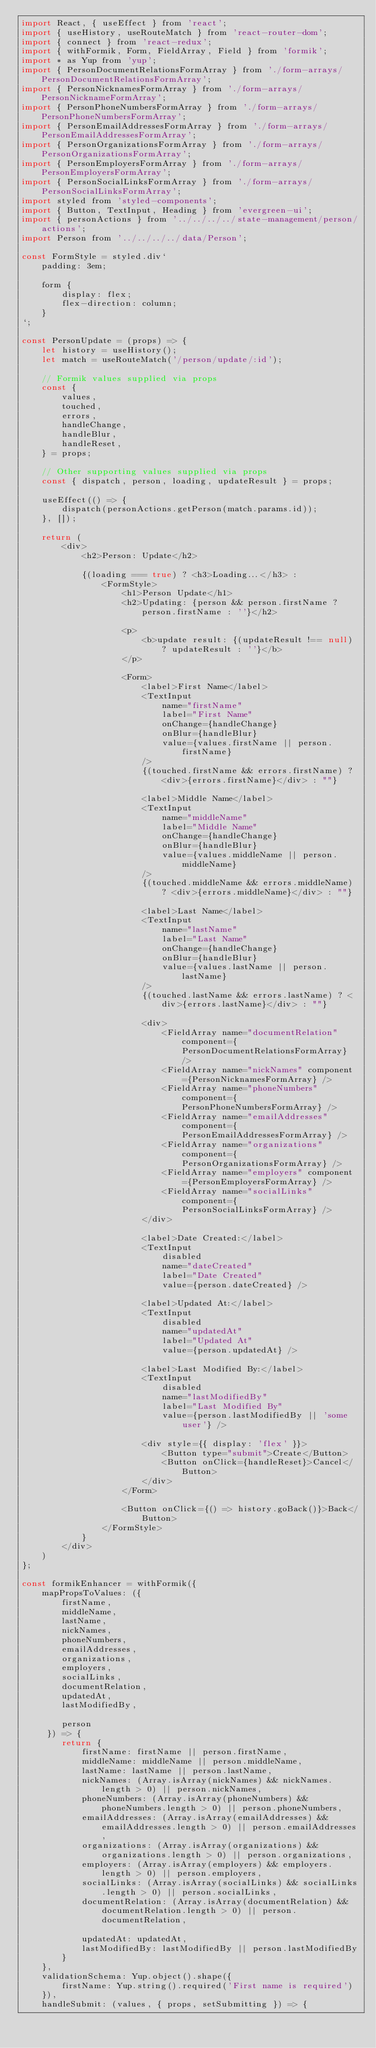<code> <loc_0><loc_0><loc_500><loc_500><_JavaScript_>import React, { useEffect } from 'react';
import { useHistory, useRouteMatch } from 'react-router-dom';
import { connect } from 'react-redux';
import { withFormik, Form, FieldArray, Field } from 'formik';
import * as Yup from 'yup';
import { PersonDocumentRelationsFormArray } from './form-arrays/PersonDocumentRelationsFormArray';
import { PersonNicknamesFormArray } from './form-arrays/PersonNicknameFormArray';
import { PersonPhoneNumbersFormArray } from './form-arrays/PersonPhoneNumbersFormArray';
import { PersonEmailAddressesFormArray } from './form-arrays/PersonEmailAddressesFormArray';
import { PersonOrganizationsFormArray } from './form-arrays/PersonOrganizationsFormArray';
import { PersonEmployersFormArray } from './form-arrays/PersonEmployersFormArray';
import { PersonSocialLinksFormArray } from './form-arrays/PersonSocialLinksFormArray';
import styled from 'styled-components';
import { Button, TextInput, Heading } from 'evergreen-ui';
import { personActions } from '../../../../state-management/person/actions';
import Person from '../../../../data/Person';

const FormStyle = styled.div`
    padding: 3em;    

    form {
        display: flex;
        flex-direction: column;
    }
`;

const PersonUpdate = (props) => {
    let history = useHistory();
    let match = useRouteMatch('/person/update/:id');
    
    // Formik values supplied via props
    const {
        values,
        touched,
        errors,
        handleChange,
        handleBlur,
        handleReset,
    } = props;

    // Other supporting values supplied via props
    const { dispatch, person, loading, updateResult } = props;

    useEffect(() => {
        dispatch(personActions.getPerson(match.params.id));
    }, []);

    return (
        <div>
            <h2>Person: Update</h2>

            {(loading === true) ? <h3>Loading...</h3> : 
                <FormStyle>
                    <h1>Person Update</h1>
                    <h2>Updating: {person && person.firstName ? person.firstName : ''}</h2>

                    <p>
                        <b>update result: {(updateResult !== null) ? updateResult : ''}</b>
                    </p>

                    <Form>
                        <label>First Name</label>
                        <TextInput 
                            name="firstName"
                            label="First Name"
                            onChange={handleChange}
                            onBlur={handleBlur}
                            value={values.firstName || person.firstName}
                        />
                        {(touched.firstName && errors.firstName) ? <div>{errors.firstName}</div> : ""}

                        <label>Middle Name</label>
                        <TextInput 
                            name="middleName"
                            label="Middle Name"
                            onChange={handleChange}
                            onBlur={handleBlur}
                            value={values.middleName || person.middleName}
                        />
                        {(touched.middleName && errors.middleName) ? <div>{errors.middleName}</div> : ""}

                        <label>Last Name</label>
                        <TextInput 
                            name="lastName"
                            label="Last Name"
                            onChange={handleChange}
                            onBlur={handleBlur}
                            value={values.lastName || person.lastName}
                        />
                        {(touched.lastName && errors.lastName) ? <div>{errors.lastName}</div> : ""}

                        <div>
                            <FieldArray name="documentRelation" component={PersonDocumentRelationsFormArray} />
                            <FieldArray name="nickNames" component={PersonNicknamesFormArray} />
                            <FieldArray name="phoneNumbers" component={PersonPhoneNumbersFormArray} />
                            <FieldArray name="emailAddresses" component={PersonEmailAddressesFormArray} />
                            <FieldArray name="organizations" component={PersonOrganizationsFormArray} />
                            <FieldArray name="employers" component={PersonEmployersFormArray} />
                            <FieldArray name="socialLinks" component={PersonSocialLinksFormArray} />
                        </div>

                        <label>Date Created:</label>
                        <TextInput 
                            disabled 
                            name="dateCreated"
                            label="Date Created"
                            value={person.dateCreated} />

                        <label>Updated At:</label>
                        <TextInput 
                            disabled 
                            name="updatedAt"
                            label="Updated At"
                            value={person.updatedAt} />

                        <label>Last Modified By:</label>
                        <TextInput 
                            disabled 
                            name="lastModifiedBy"
                            label="Last Modified By"
                            value={person.lastModifiedBy || 'some user'} />
                        
                        <div style={{ display: 'flex' }}>
                            <Button type="submit">Create</Button>
                            <Button onClick={handleReset}>Cancel</Button>
                        </div>
                    </Form>

                    <Button onClick={() => history.goBack()}>Back</Button>
                </FormStyle>
            }
        </div>
    )
};

const formikEnhancer = withFormik({
    mapPropsToValues: ({ 
        firstName,
        middleName,
        lastName,
        nickNames,
        phoneNumbers,
        emailAddresses,
        organizations,
        employers,
        socialLinks,
        documentRelation,
        updatedAt,
        lastModifiedBy,

        person
     }) => {
        return {
            firstName: firstName || person.firstName,
            middleName: middleName || person.middleName,
            lastName: lastName || person.lastName,
            nickNames: (Array.isArray(nickNames) && nickNames.length > 0) || person.nickNames,
            phoneNumbers: (Array.isArray(phoneNumbers) && phoneNumbers.length > 0) || person.phoneNumbers,
            emailAddresses: (Array.isArray(emailAddresses) && emailAddresses.length > 0) || person.emailAddresses,
            organizations: (Array.isArray(organizations) && organizations.length > 0) || person.organizations,
            employers: (Array.isArray(employers) && employers.length > 0) || person.employers,
            socialLinks: (Array.isArray(socialLinks) && socialLinks.length > 0) || person.socialLinks,
            documentRelation: (Array.isArray(documentRelation) && documentRelation.length > 0) || person.documentRelation,

            updatedAt: updatedAt,
            lastModifiedBy: lastModifiedBy || person.lastModifiedBy
        }
    },
    validationSchema: Yup.object().shape({
        firstName: Yup.string().required('First name is required')
    }),
    handleSubmit: (values, { props, setSubmitting }) => {</code> 